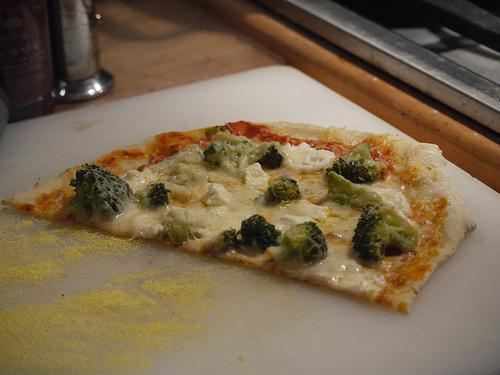How many pizzas are in the picture?
Give a very brief answer. 1. 